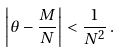Convert formula to latex. <formula><loc_0><loc_0><loc_500><loc_500>\left | \theta - \frac { M } { N } \right | < \frac { 1 } { N ^ { 2 } } \, .</formula> 